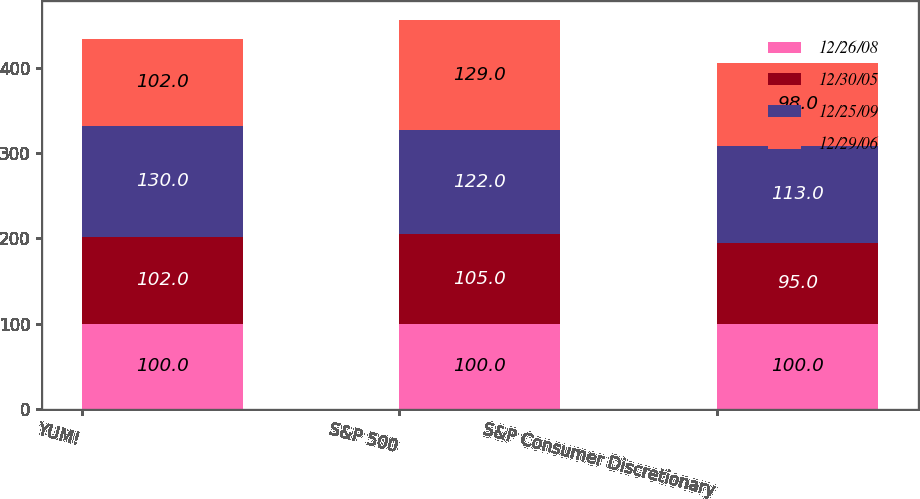Convert chart. <chart><loc_0><loc_0><loc_500><loc_500><stacked_bar_chart><ecel><fcel>YUM!<fcel>S&P 500<fcel>S&P Consumer Discretionary<nl><fcel>12/26/08<fcel>100<fcel>100<fcel>100<nl><fcel>12/30/05<fcel>102<fcel>105<fcel>95<nl><fcel>12/25/09<fcel>130<fcel>122<fcel>113<nl><fcel>12/29/06<fcel>102<fcel>129<fcel>98<nl></chart> 